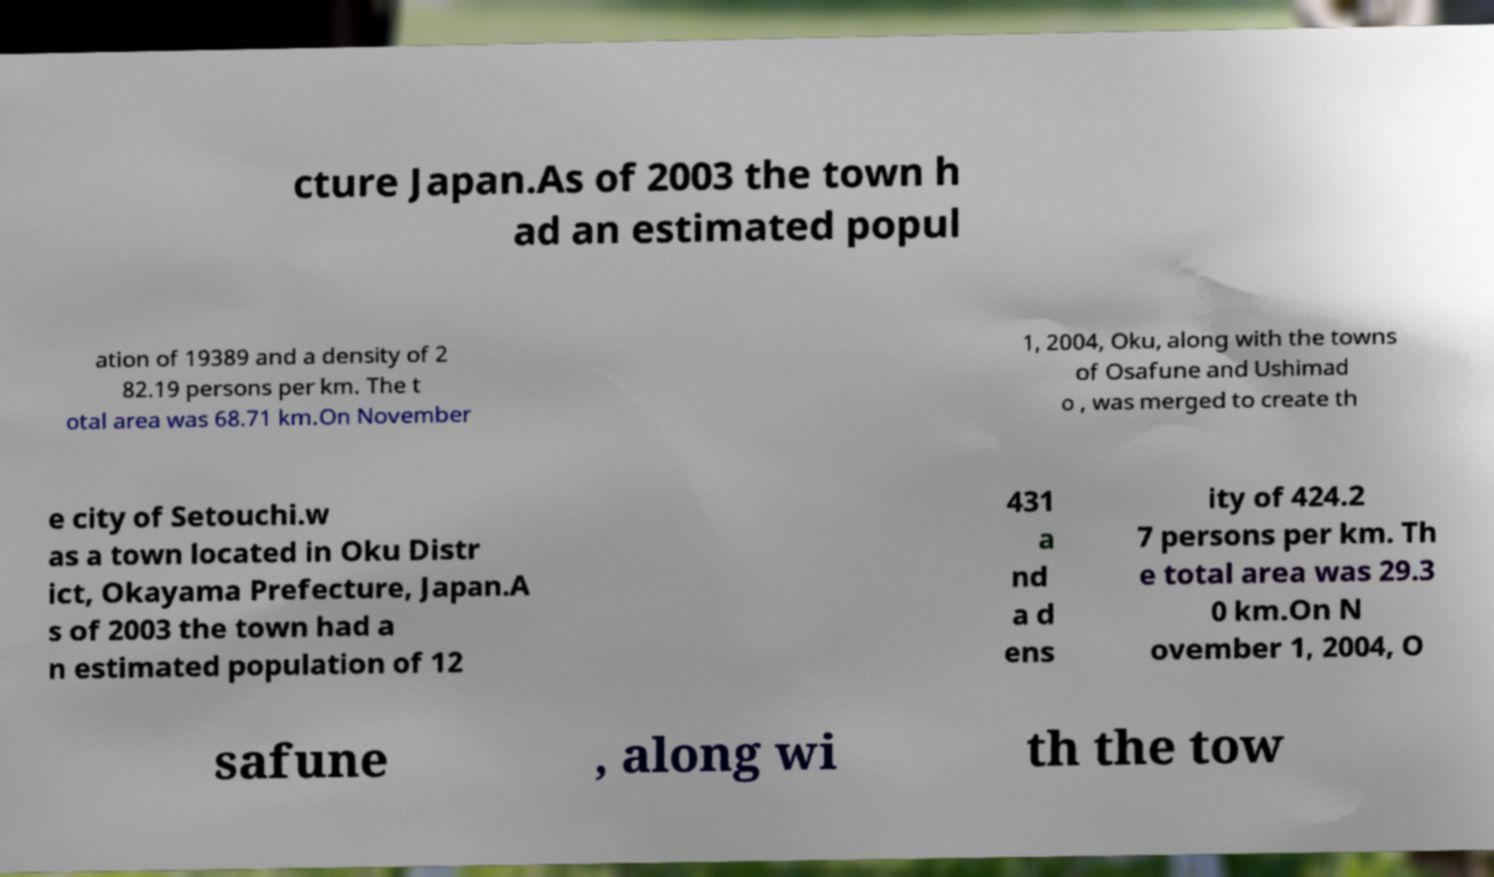Can you accurately transcribe the text from the provided image for me? cture Japan.As of 2003 the town h ad an estimated popul ation of 19389 and a density of 2 82.19 persons per km. The t otal area was 68.71 km.On November 1, 2004, Oku, along with the towns of Osafune and Ushimad o , was merged to create th e city of Setouchi.w as a town located in Oku Distr ict, Okayama Prefecture, Japan.A s of 2003 the town had a n estimated population of 12 431 a nd a d ens ity of 424.2 7 persons per km. Th e total area was 29.3 0 km.On N ovember 1, 2004, O safune , along wi th the tow 